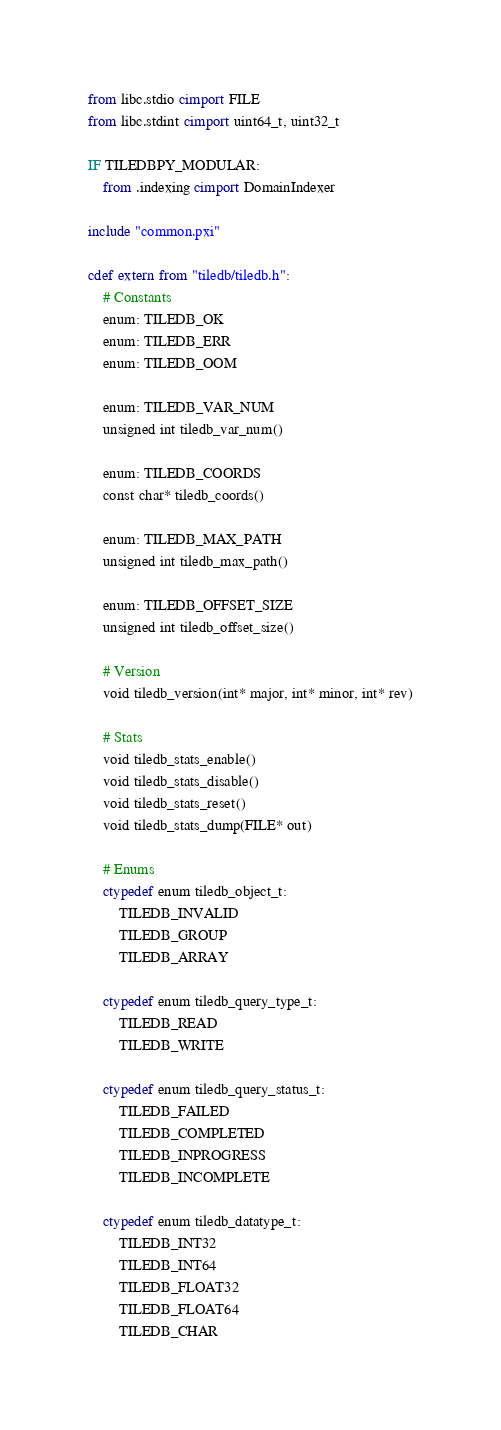Convert code to text. <code><loc_0><loc_0><loc_500><loc_500><_Cython_>from libc.stdio cimport FILE
from libc.stdint cimport uint64_t, uint32_t

IF TILEDBPY_MODULAR:
    from .indexing cimport DomainIndexer

include "common.pxi"

cdef extern from "tiledb/tiledb.h":
    # Constants
    enum: TILEDB_OK
    enum: TILEDB_ERR
    enum: TILEDB_OOM

    enum: TILEDB_VAR_NUM
    unsigned int tiledb_var_num()

    enum: TILEDB_COORDS
    const char* tiledb_coords()

    enum: TILEDB_MAX_PATH
    unsigned int tiledb_max_path()

    enum: TILEDB_OFFSET_SIZE
    unsigned int tiledb_offset_size()

    # Version
    void tiledb_version(int* major, int* minor, int* rev)

    # Stats
    void tiledb_stats_enable()
    void tiledb_stats_disable()
    void tiledb_stats_reset()
    void tiledb_stats_dump(FILE* out)

    # Enums
    ctypedef enum tiledb_object_t:
        TILEDB_INVALID
        TILEDB_GROUP
        TILEDB_ARRAY

    ctypedef enum tiledb_query_type_t:
        TILEDB_READ
        TILEDB_WRITE

    ctypedef enum tiledb_query_status_t:
        TILEDB_FAILED
        TILEDB_COMPLETED
        TILEDB_INPROGRESS
        TILEDB_INCOMPLETE

    ctypedef enum tiledb_datatype_t:
        TILEDB_INT32
        TILEDB_INT64
        TILEDB_FLOAT32
        TILEDB_FLOAT64
        TILEDB_CHAR</code> 